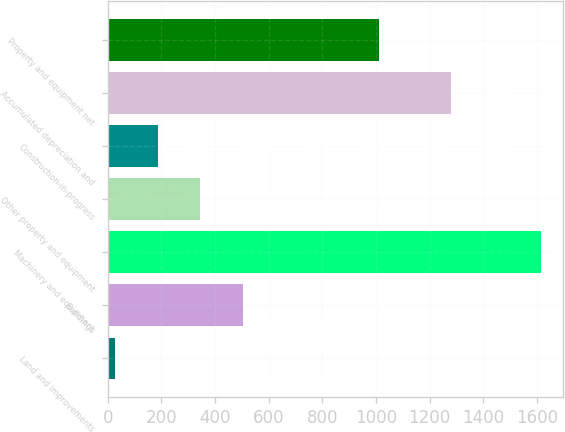Convert chart. <chart><loc_0><loc_0><loc_500><loc_500><bar_chart><fcel>Land and improvements<fcel>Buildings<fcel>Machinery and equipment<fcel>Other property and equipment<fcel>Construction-in-progress<fcel>Accumulated depreciation and<fcel>Property and equipment net<nl><fcel>27.4<fcel>503.98<fcel>1616<fcel>345.12<fcel>186.26<fcel>1279.5<fcel>1013<nl></chart> 